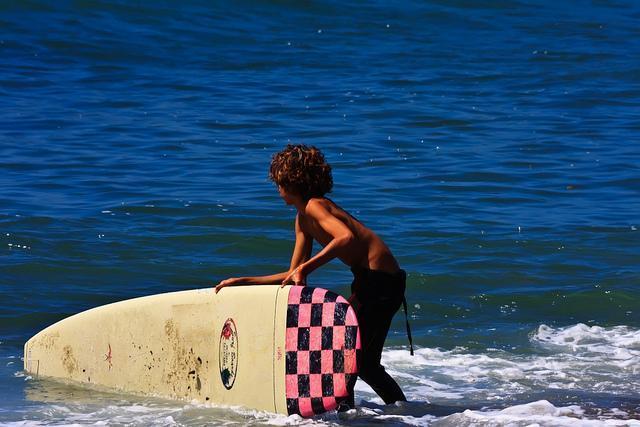How many people are in the water?
Give a very brief answer. 1. 